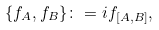Convert formula to latex. <formula><loc_0><loc_0><loc_500><loc_500>\{ f _ { A } , f _ { B } \} \colon = i f _ { [ A , B ] } ,</formula> 